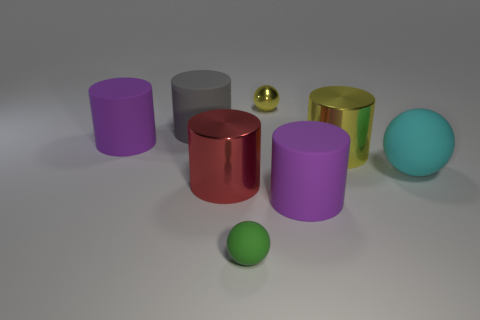How many metal cylinders have the same color as the tiny metal ball?
Offer a very short reply. 1. There is a large matte object in front of the large cyan sphere; is its color the same as the big shiny thing that is to the left of the small metallic ball?
Offer a terse response. No. There is a large thing that is both to the right of the red cylinder and left of the big yellow shiny cylinder; what shape is it?
Make the answer very short. Cylinder. Are there any small blue metal things that have the same shape as the big red thing?
Provide a succinct answer. No. What shape is the gray object that is the same size as the yellow cylinder?
Offer a terse response. Cylinder. What material is the big yellow cylinder?
Offer a very short reply. Metal. What is the size of the ball on the right side of the yellow thing in front of the big purple rubber cylinder that is behind the large cyan thing?
Keep it short and to the point. Large. What material is the cylinder that is the same color as the tiny metal sphere?
Make the answer very short. Metal. What number of metallic objects are green spheres or big red cylinders?
Offer a terse response. 1. How big is the green ball?
Offer a very short reply. Small. 